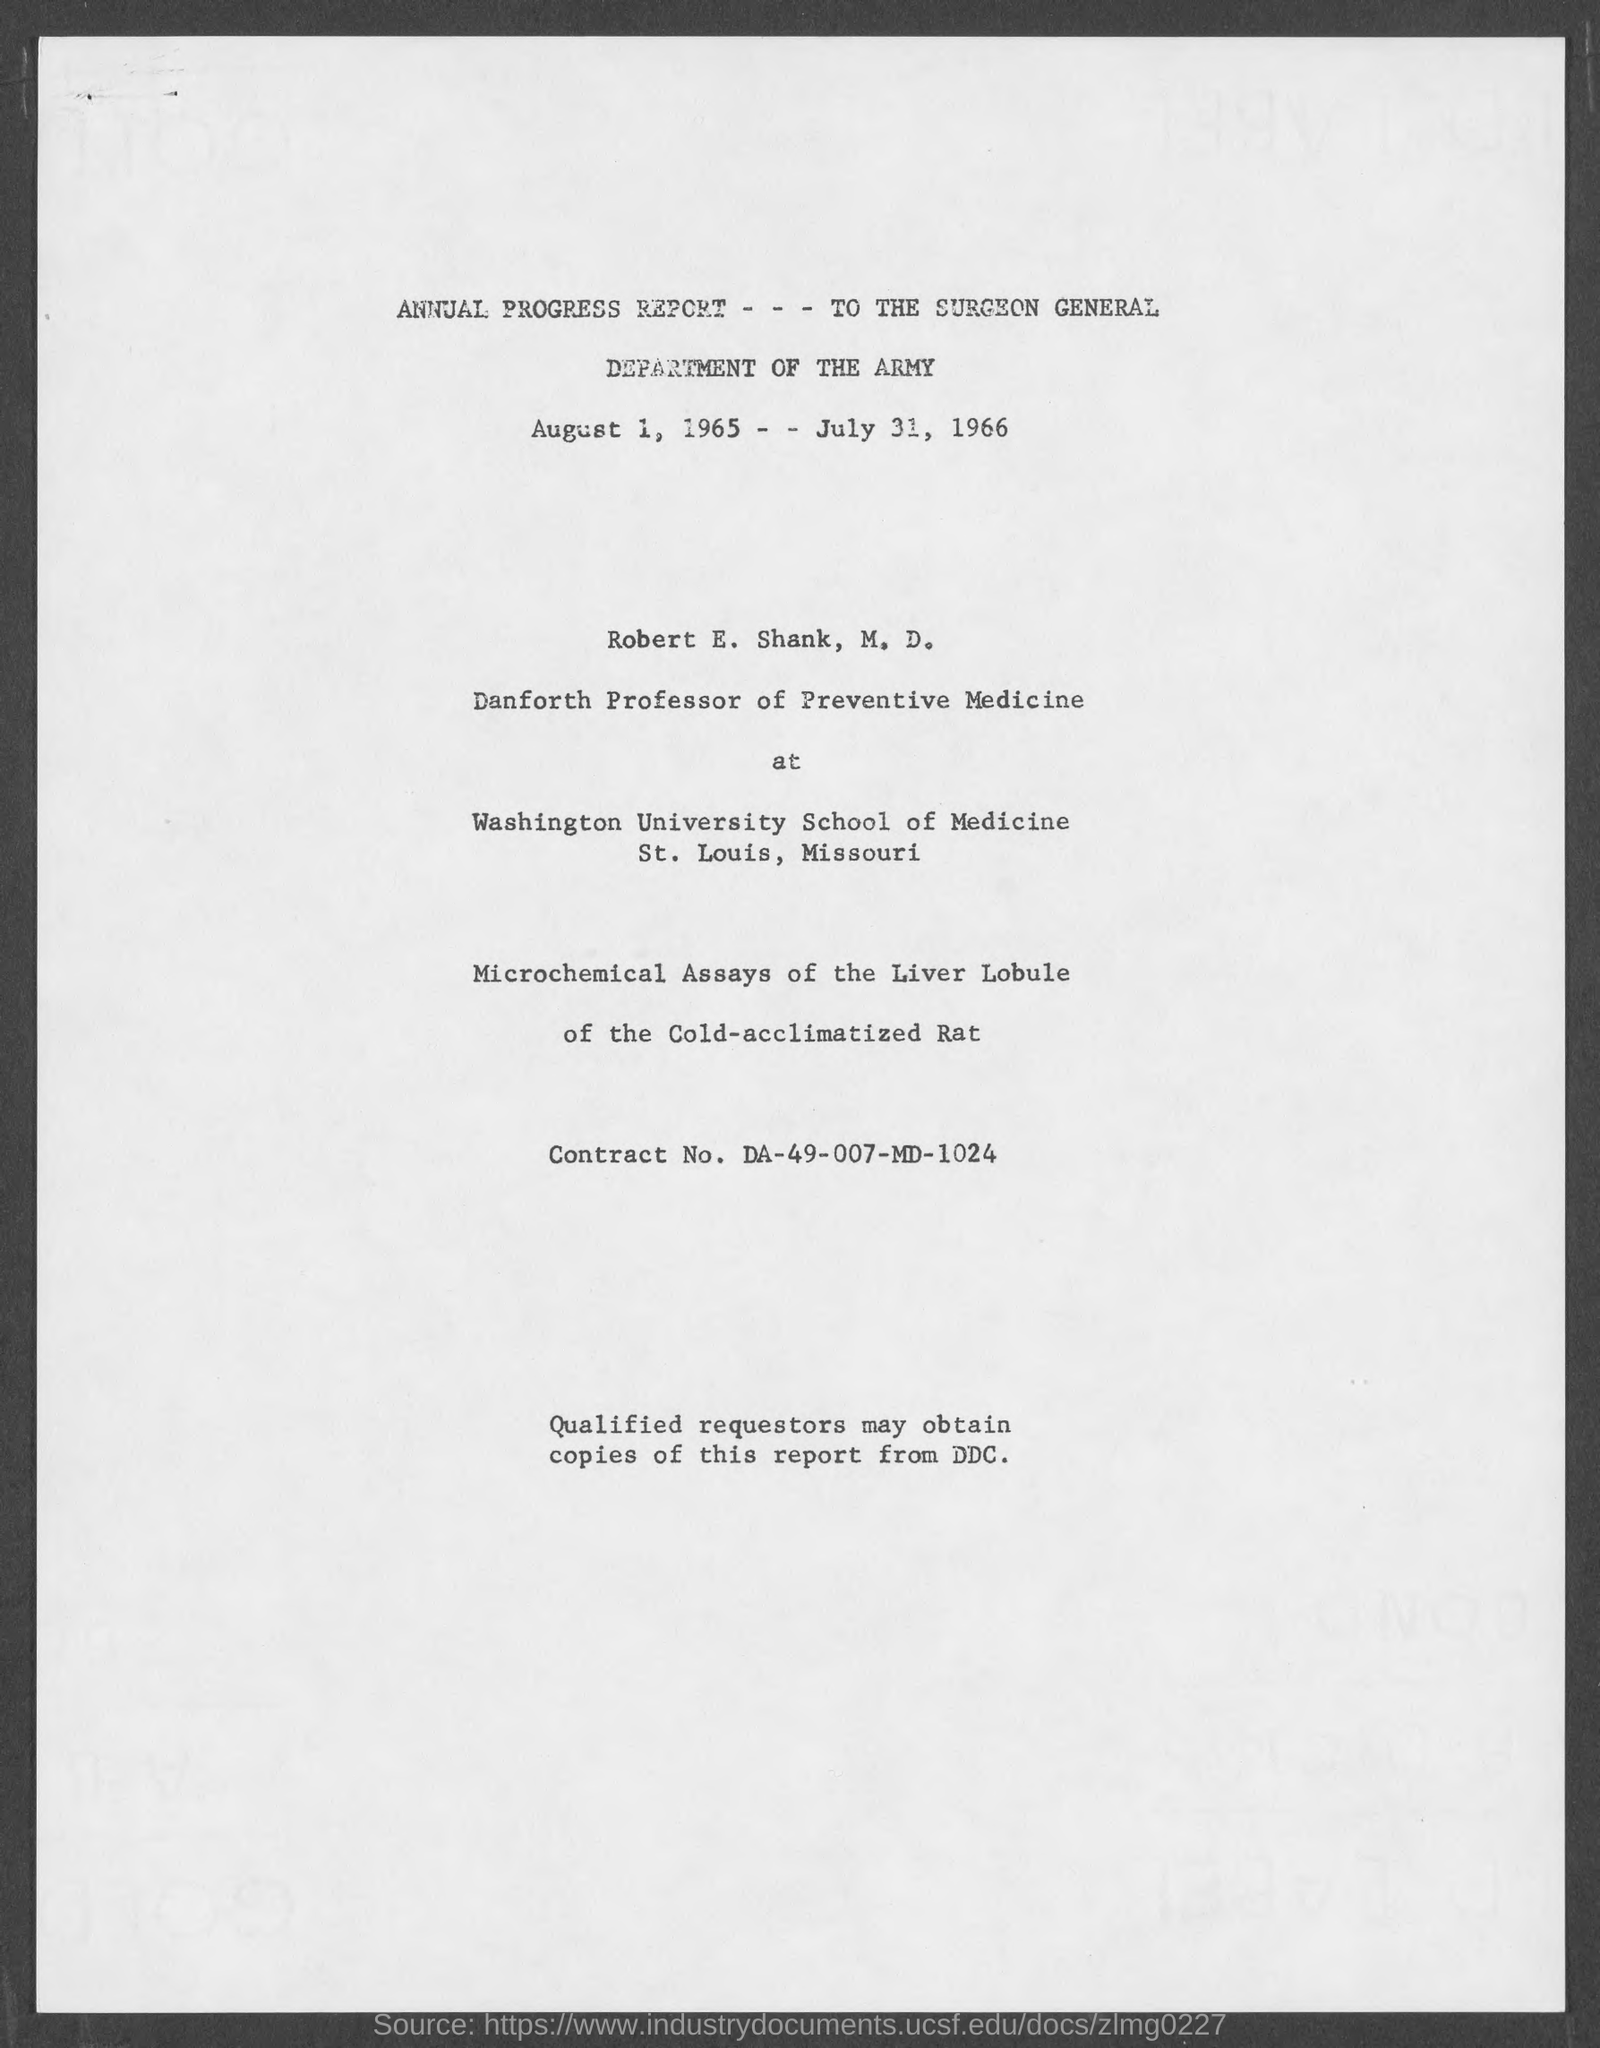Outline some significant characteristics in this image. The contract number is DA-49-007-MD-1024. Robert E. Shank, M.D. holds the position of Danforth Professor of Preventive Medicine. 